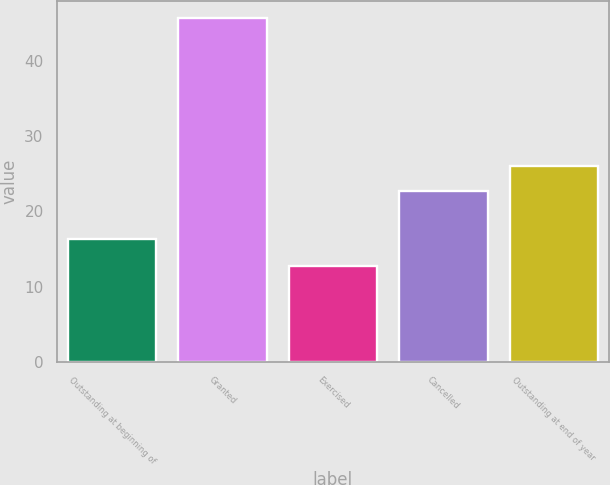Convert chart to OTSL. <chart><loc_0><loc_0><loc_500><loc_500><bar_chart><fcel>Outstanding at beginning of<fcel>Granted<fcel>Exercised<fcel>Cancelled<fcel>Outstanding at end of year<nl><fcel>16.38<fcel>45.63<fcel>12.81<fcel>22.68<fcel>25.96<nl></chart> 